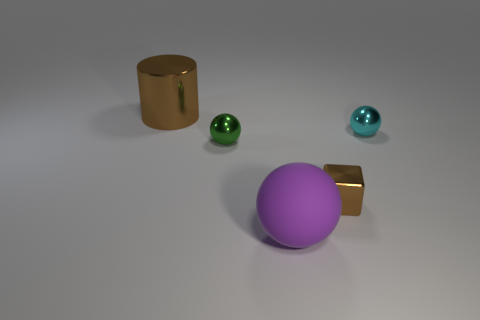There is a small thing that is the same color as the large cylinder; what material is it?
Provide a succinct answer. Metal. Do the shiny cube and the metal cylinder have the same color?
Make the answer very short. Yes. Is the color of the thing behind the small cyan sphere the same as the small metal block?
Offer a very short reply. Yes. Is there any other thing that has the same material as the purple sphere?
Provide a short and direct response. No. Does the tiny thing in front of the green shiny object have the same material as the cyan sphere?
Your answer should be very brief. Yes. What number of things are either cylinders or matte spheres that are to the right of the cylinder?
Provide a succinct answer. 2. What number of small metallic things are behind the brown object in front of the brown thing that is to the left of the shiny cube?
Provide a succinct answer. 2. There is a large object in front of the brown metallic cylinder; is its shape the same as the tiny cyan metallic thing?
Offer a very short reply. Yes. Are there any purple objects that are on the left side of the big object that is to the left of the big matte thing?
Provide a short and direct response. No. What number of purple balls are there?
Provide a succinct answer. 1. 